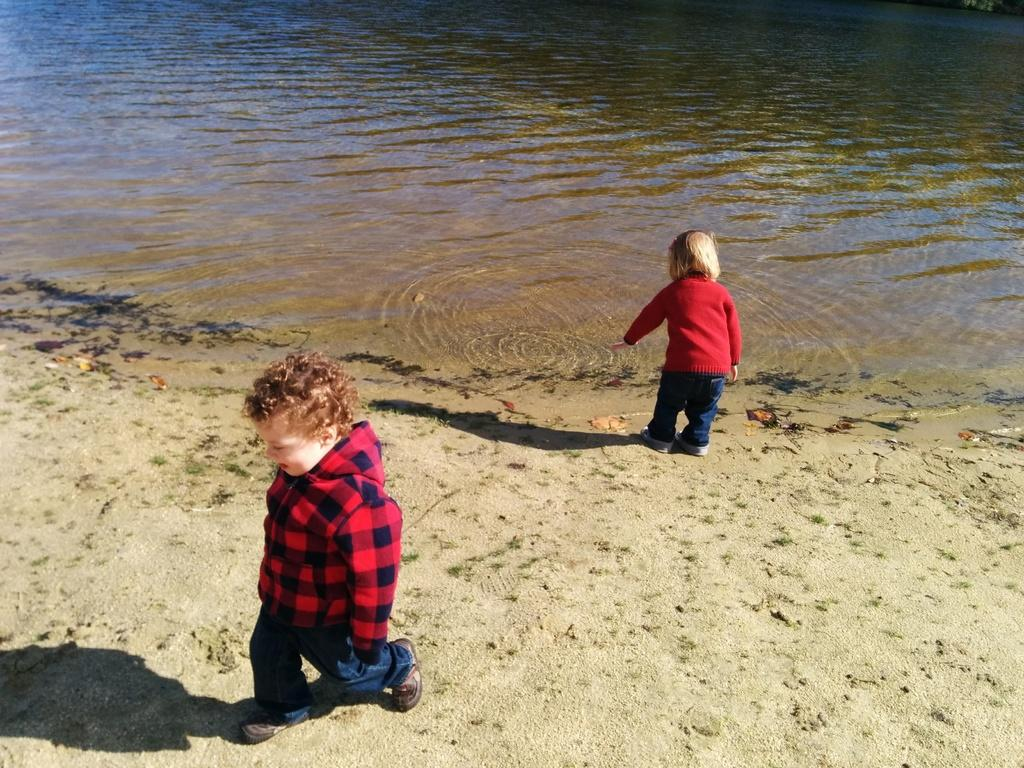How many children are present in the image? There are two kids in the image. Where are the kids located in the image? The kids are near a lake. What can be seen in the background of the image? There is water visible in the background of the image. What type of disease is affecting the kids in the image? There is no indication of any disease affecting the kids in the image. How are the kids pulling the water in the image? The kids are not pulling the water in the image; they are simply near a lake. 